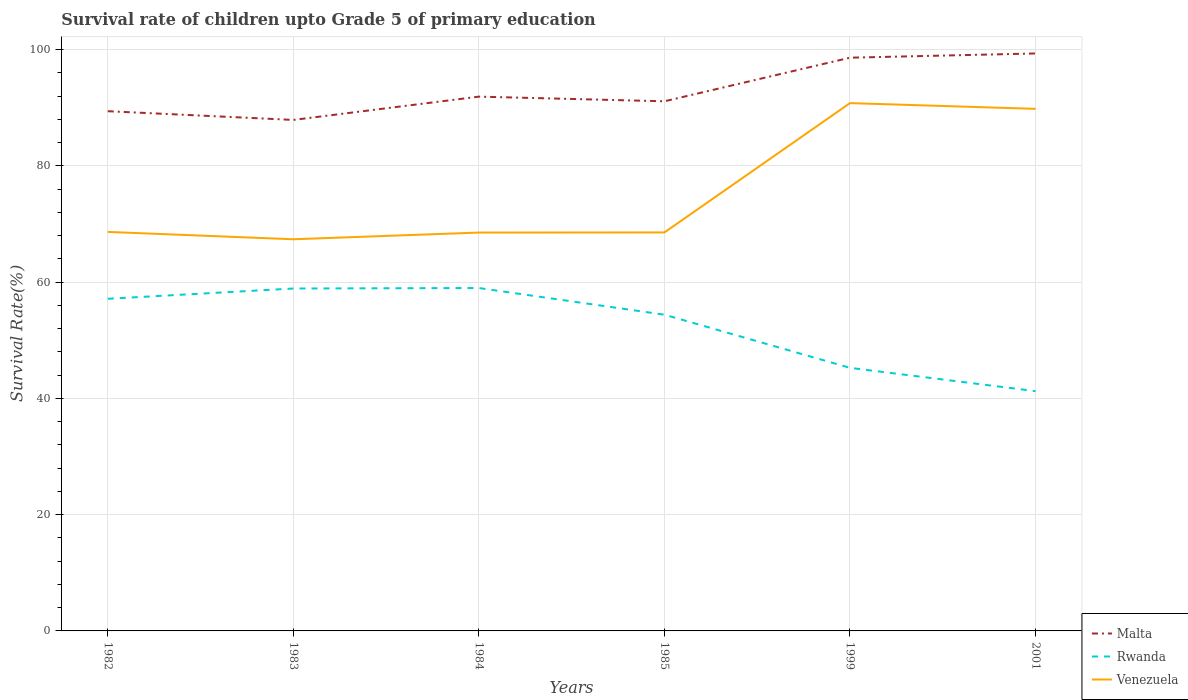How many different coloured lines are there?
Your answer should be compact. 3. Does the line corresponding to Venezuela intersect with the line corresponding to Rwanda?
Your answer should be very brief. No. Is the number of lines equal to the number of legend labels?
Offer a very short reply. Yes. Across all years, what is the maximum survival rate of children in Malta?
Make the answer very short. 87.9. What is the total survival rate of children in Rwanda in the graph?
Your response must be concise. 15.89. What is the difference between the highest and the second highest survival rate of children in Venezuela?
Offer a terse response. 23.42. How many lines are there?
Give a very brief answer. 3. Are the values on the major ticks of Y-axis written in scientific E-notation?
Your answer should be compact. No. Does the graph contain any zero values?
Your answer should be compact. No. How many legend labels are there?
Offer a terse response. 3. How are the legend labels stacked?
Make the answer very short. Vertical. What is the title of the graph?
Keep it short and to the point. Survival rate of children upto Grade 5 of primary education. Does "Virgin Islands" appear as one of the legend labels in the graph?
Give a very brief answer. No. What is the label or title of the X-axis?
Your response must be concise. Years. What is the label or title of the Y-axis?
Offer a terse response. Survival Rate(%). What is the Survival Rate(%) of Malta in 1982?
Offer a terse response. 89.4. What is the Survival Rate(%) in Rwanda in 1982?
Provide a succinct answer. 57.14. What is the Survival Rate(%) in Venezuela in 1982?
Ensure brevity in your answer.  68.64. What is the Survival Rate(%) of Malta in 1983?
Your answer should be compact. 87.9. What is the Survival Rate(%) in Rwanda in 1983?
Ensure brevity in your answer.  58.9. What is the Survival Rate(%) in Venezuela in 1983?
Make the answer very short. 67.37. What is the Survival Rate(%) of Malta in 1984?
Provide a succinct answer. 91.91. What is the Survival Rate(%) in Rwanda in 1984?
Ensure brevity in your answer.  58.99. What is the Survival Rate(%) of Venezuela in 1984?
Keep it short and to the point. 68.53. What is the Survival Rate(%) in Malta in 1985?
Ensure brevity in your answer.  91.11. What is the Survival Rate(%) in Rwanda in 1985?
Offer a terse response. 54.4. What is the Survival Rate(%) of Venezuela in 1985?
Offer a very short reply. 68.55. What is the Survival Rate(%) in Malta in 1999?
Your answer should be very brief. 98.61. What is the Survival Rate(%) of Rwanda in 1999?
Give a very brief answer. 45.26. What is the Survival Rate(%) in Venezuela in 1999?
Make the answer very short. 90.8. What is the Survival Rate(%) in Malta in 2001?
Offer a very short reply. 99.34. What is the Survival Rate(%) of Rwanda in 2001?
Ensure brevity in your answer.  41.25. What is the Survival Rate(%) of Venezuela in 2001?
Offer a very short reply. 89.81. Across all years, what is the maximum Survival Rate(%) of Malta?
Keep it short and to the point. 99.34. Across all years, what is the maximum Survival Rate(%) in Rwanda?
Keep it short and to the point. 58.99. Across all years, what is the maximum Survival Rate(%) in Venezuela?
Provide a short and direct response. 90.8. Across all years, what is the minimum Survival Rate(%) of Malta?
Your answer should be very brief. 87.9. Across all years, what is the minimum Survival Rate(%) in Rwanda?
Give a very brief answer. 41.25. Across all years, what is the minimum Survival Rate(%) of Venezuela?
Your response must be concise. 67.37. What is the total Survival Rate(%) of Malta in the graph?
Ensure brevity in your answer.  558.27. What is the total Survival Rate(%) of Rwanda in the graph?
Your answer should be compact. 315.93. What is the total Survival Rate(%) in Venezuela in the graph?
Make the answer very short. 453.7. What is the difference between the Survival Rate(%) of Malta in 1982 and that in 1983?
Your response must be concise. 1.5. What is the difference between the Survival Rate(%) of Rwanda in 1982 and that in 1983?
Your answer should be very brief. -1.77. What is the difference between the Survival Rate(%) of Venezuela in 1982 and that in 1983?
Your response must be concise. 1.26. What is the difference between the Survival Rate(%) of Malta in 1982 and that in 1984?
Offer a very short reply. -2.5. What is the difference between the Survival Rate(%) in Rwanda in 1982 and that in 1984?
Offer a very short reply. -1.85. What is the difference between the Survival Rate(%) in Venezuela in 1982 and that in 1984?
Provide a short and direct response. 0.11. What is the difference between the Survival Rate(%) in Malta in 1982 and that in 1985?
Your answer should be very brief. -1.7. What is the difference between the Survival Rate(%) of Rwanda in 1982 and that in 1985?
Provide a succinct answer. 2.74. What is the difference between the Survival Rate(%) of Venezuela in 1982 and that in 1985?
Offer a terse response. 0.09. What is the difference between the Survival Rate(%) in Malta in 1982 and that in 1999?
Your answer should be compact. -9.2. What is the difference between the Survival Rate(%) in Rwanda in 1982 and that in 1999?
Offer a very short reply. 11.88. What is the difference between the Survival Rate(%) in Venezuela in 1982 and that in 1999?
Offer a very short reply. -22.16. What is the difference between the Survival Rate(%) in Malta in 1982 and that in 2001?
Offer a very short reply. -9.93. What is the difference between the Survival Rate(%) of Rwanda in 1982 and that in 2001?
Keep it short and to the point. 15.89. What is the difference between the Survival Rate(%) of Venezuela in 1982 and that in 2001?
Provide a short and direct response. -21.17. What is the difference between the Survival Rate(%) of Malta in 1983 and that in 1984?
Give a very brief answer. -4.01. What is the difference between the Survival Rate(%) in Rwanda in 1983 and that in 1984?
Give a very brief answer. -0.09. What is the difference between the Survival Rate(%) of Venezuela in 1983 and that in 1984?
Give a very brief answer. -1.15. What is the difference between the Survival Rate(%) of Malta in 1983 and that in 1985?
Ensure brevity in your answer.  -3.21. What is the difference between the Survival Rate(%) of Rwanda in 1983 and that in 1985?
Provide a succinct answer. 4.5. What is the difference between the Survival Rate(%) of Venezuela in 1983 and that in 1985?
Ensure brevity in your answer.  -1.18. What is the difference between the Survival Rate(%) of Malta in 1983 and that in 1999?
Provide a short and direct response. -10.71. What is the difference between the Survival Rate(%) of Rwanda in 1983 and that in 1999?
Keep it short and to the point. 13.65. What is the difference between the Survival Rate(%) in Venezuela in 1983 and that in 1999?
Provide a succinct answer. -23.42. What is the difference between the Survival Rate(%) in Malta in 1983 and that in 2001?
Offer a very short reply. -11.44. What is the difference between the Survival Rate(%) in Rwanda in 1983 and that in 2001?
Offer a very short reply. 17.65. What is the difference between the Survival Rate(%) in Venezuela in 1983 and that in 2001?
Your answer should be compact. -22.43. What is the difference between the Survival Rate(%) of Malta in 1984 and that in 1985?
Your answer should be compact. 0.8. What is the difference between the Survival Rate(%) in Rwanda in 1984 and that in 1985?
Your response must be concise. 4.59. What is the difference between the Survival Rate(%) of Venezuela in 1984 and that in 1985?
Ensure brevity in your answer.  -0.02. What is the difference between the Survival Rate(%) of Malta in 1984 and that in 1999?
Ensure brevity in your answer.  -6.7. What is the difference between the Survival Rate(%) in Rwanda in 1984 and that in 1999?
Your response must be concise. 13.73. What is the difference between the Survival Rate(%) of Venezuela in 1984 and that in 1999?
Your answer should be compact. -22.27. What is the difference between the Survival Rate(%) of Malta in 1984 and that in 2001?
Your answer should be very brief. -7.43. What is the difference between the Survival Rate(%) of Rwanda in 1984 and that in 2001?
Offer a very short reply. 17.74. What is the difference between the Survival Rate(%) in Venezuela in 1984 and that in 2001?
Offer a very short reply. -21.28. What is the difference between the Survival Rate(%) in Malta in 1985 and that in 1999?
Your answer should be compact. -7.5. What is the difference between the Survival Rate(%) in Rwanda in 1985 and that in 1999?
Provide a succinct answer. 9.14. What is the difference between the Survival Rate(%) of Venezuela in 1985 and that in 1999?
Offer a very short reply. -22.25. What is the difference between the Survival Rate(%) of Malta in 1985 and that in 2001?
Provide a short and direct response. -8.23. What is the difference between the Survival Rate(%) in Rwanda in 1985 and that in 2001?
Make the answer very short. 13.15. What is the difference between the Survival Rate(%) in Venezuela in 1985 and that in 2001?
Make the answer very short. -21.26. What is the difference between the Survival Rate(%) in Malta in 1999 and that in 2001?
Your answer should be very brief. -0.73. What is the difference between the Survival Rate(%) of Rwanda in 1999 and that in 2001?
Give a very brief answer. 4.01. What is the difference between the Survival Rate(%) of Malta in 1982 and the Survival Rate(%) of Rwanda in 1983?
Provide a short and direct response. 30.5. What is the difference between the Survival Rate(%) in Malta in 1982 and the Survival Rate(%) in Venezuela in 1983?
Provide a short and direct response. 22.03. What is the difference between the Survival Rate(%) of Rwanda in 1982 and the Survival Rate(%) of Venezuela in 1983?
Provide a short and direct response. -10.24. What is the difference between the Survival Rate(%) of Malta in 1982 and the Survival Rate(%) of Rwanda in 1984?
Your response must be concise. 30.42. What is the difference between the Survival Rate(%) in Malta in 1982 and the Survival Rate(%) in Venezuela in 1984?
Provide a short and direct response. 20.88. What is the difference between the Survival Rate(%) of Rwanda in 1982 and the Survival Rate(%) of Venezuela in 1984?
Make the answer very short. -11.39. What is the difference between the Survival Rate(%) in Malta in 1982 and the Survival Rate(%) in Rwanda in 1985?
Provide a short and direct response. 35.01. What is the difference between the Survival Rate(%) of Malta in 1982 and the Survival Rate(%) of Venezuela in 1985?
Offer a terse response. 20.86. What is the difference between the Survival Rate(%) in Rwanda in 1982 and the Survival Rate(%) in Venezuela in 1985?
Offer a very short reply. -11.41. What is the difference between the Survival Rate(%) of Malta in 1982 and the Survival Rate(%) of Rwanda in 1999?
Keep it short and to the point. 44.15. What is the difference between the Survival Rate(%) of Malta in 1982 and the Survival Rate(%) of Venezuela in 1999?
Offer a terse response. -1.39. What is the difference between the Survival Rate(%) in Rwanda in 1982 and the Survival Rate(%) in Venezuela in 1999?
Make the answer very short. -33.66. What is the difference between the Survival Rate(%) in Malta in 1982 and the Survival Rate(%) in Rwanda in 2001?
Keep it short and to the point. 48.16. What is the difference between the Survival Rate(%) of Malta in 1982 and the Survival Rate(%) of Venezuela in 2001?
Give a very brief answer. -0.4. What is the difference between the Survival Rate(%) in Rwanda in 1982 and the Survival Rate(%) in Venezuela in 2001?
Give a very brief answer. -32.67. What is the difference between the Survival Rate(%) in Malta in 1983 and the Survival Rate(%) in Rwanda in 1984?
Provide a succinct answer. 28.91. What is the difference between the Survival Rate(%) of Malta in 1983 and the Survival Rate(%) of Venezuela in 1984?
Your answer should be very brief. 19.37. What is the difference between the Survival Rate(%) in Rwanda in 1983 and the Survival Rate(%) in Venezuela in 1984?
Keep it short and to the point. -9.62. What is the difference between the Survival Rate(%) in Malta in 1983 and the Survival Rate(%) in Rwanda in 1985?
Your answer should be very brief. 33.5. What is the difference between the Survival Rate(%) in Malta in 1983 and the Survival Rate(%) in Venezuela in 1985?
Ensure brevity in your answer.  19.35. What is the difference between the Survival Rate(%) in Rwanda in 1983 and the Survival Rate(%) in Venezuela in 1985?
Offer a terse response. -9.65. What is the difference between the Survival Rate(%) of Malta in 1983 and the Survival Rate(%) of Rwanda in 1999?
Provide a succinct answer. 42.64. What is the difference between the Survival Rate(%) in Malta in 1983 and the Survival Rate(%) in Venezuela in 1999?
Your answer should be very brief. -2.9. What is the difference between the Survival Rate(%) in Rwanda in 1983 and the Survival Rate(%) in Venezuela in 1999?
Make the answer very short. -31.89. What is the difference between the Survival Rate(%) of Malta in 1983 and the Survival Rate(%) of Rwanda in 2001?
Keep it short and to the point. 46.65. What is the difference between the Survival Rate(%) in Malta in 1983 and the Survival Rate(%) in Venezuela in 2001?
Offer a terse response. -1.91. What is the difference between the Survival Rate(%) in Rwanda in 1983 and the Survival Rate(%) in Venezuela in 2001?
Offer a terse response. -30.91. What is the difference between the Survival Rate(%) in Malta in 1984 and the Survival Rate(%) in Rwanda in 1985?
Make the answer very short. 37.51. What is the difference between the Survival Rate(%) in Malta in 1984 and the Survival Rate(%) in Venezuela in 1985?
Provide a short and direct response. 23.36. What is the difference between the Survival Rate(%) of Rwanda in 1984 and the Survival Rate(%) of Venezuela in 1985?
Your answer should be compact. -9.56. What is the difference between the Survival Rate(%) of Malta in 1984 and the Survival Rate(%) of Rwanda in 1999?
Your answer should be very brief. 46.65. What is the difference between the Survival Rate(%) in Malta in 1984 and the Survival Rate(%) in Venezuela in 1999?
Make the answer very short. 1.11. What is the difference between the Survival Rate(%) in Rwanda in 1984 and the Survival Rate(%) in Venezuela in 1999?
Your response must be concise. -31.81. What is the difference between the Survival Rate(%) of Malta in 1984 and the Survival Rate(%) of Rwanda in 2001?
Provide a succinct answer. 50.66. What is the difference between the Survival Rate(%) of Malta in 1984 and the Survival Rate(%) of Venezuela in 2001?
Provide a succinct answer. 2.1. What is the difference between the Survival Rate(%) in Rwanda in 1984 and the Survival Rate(%) in Venezuela in 2001?
Provide a short and direct response. -30.82. What is the difference between the Survival Rate(%) in Malta in 1985 and the Survival Rate(%) in Rwanda in 1999?
Your response must be concise. 45.85. What is the difference between the Survival Rate(%) in Malta in 1985 and the Survival Rate(%) in Venezuela in 1999?
Your response must be concise. 0.31. What is the difference between the Survival Rate(%) in Rwanda in 1985 and the Survival Rate(%) in Venezuela in 1999?
Your answer should be compact. -36.4. What is the difference between the Survival Rate(%) of Malta in 1985 and the Survival Rate(%) of Rwanda in 2001?
Provide a succinct answer. 49.86. What is the difference between the Survival Rate(%) in Malta in 1985 and the Survival Rate(%) in Venezuela in 2001?
Your answer should be compact. 1.3. What is the difference between the Survival Rate(%) of Rwanda in 1985 and the Survival Rate(%) of Venezuela in 2001?
Your answer should be very brief. -35.41. What is the difference between the Survival Rate(%) of Malta in 1999 and the Survival Rate(%) of Rwanda in 2001?
Keep it short and to the point. 57.36. What is the difference between the Survival Rate(%) of Malta in 1999 and the Survival Rate(%) of Venezuela in 2001?
Offer a very short reply. 8.8. What is the difference between the Survival Rate(%) of Rwanda in 1999 and the Survival Rate(%) of Venezuela in 2001?
Offer a terse response. -44.55. What is the average Survival Rate(%) of Malta per year?
Provide a short and direct response. 93.05. What is the average Survival Rate(%) of Rwanda per year?
Ensure brevity in your answer.  52.65. What is the average Survival Rate(%) of Venezuela per year?
Your answer should be compact. 75.62. In the year 1982, what is the difference between the Survival Rate(%) of Malta and Survival Rate(%) of Rwanda?
Make the answer very short. 32.27. In the year 1982, what is the difference between the Survival Rate(%) in Malta and Survival Rate(%) in Venezuela?
Your response must be concise. 20.77. In the year 1982, what is the difference between the Survival Rate(%) of Rwanda and Survival Rate(%) of Venezuela?
Make the answer very short. -11.5. In the year 1983, what is the difference between the Survival Rate(%) of Malta and Survival Rate(%) of Rwanda?
Provide a succinct answer. 29. In the year 1983, what is the difference between the Survival Rate(%) in Malta and Survival Rate(%) in Venezuela?
Your answer should be compact. 20.53. In the year 1983, what is the difference between the Survival Rate(%) of Rwanda and Survival Rate(%) of Venezuela?
Provide a short and direct response. -8.47. In the year 1984, what is the difference between the Survival Rate(%) of Malta and Survival Rate(%) of Rwanda?
Offer a very short reply. 32.92. In the year 1984, what is the difference between the Survival Rate(%) in Malta and Survival Rate(%) in Venezuela?
Your answer should be very brief. 23.38. In the year 1984, what is the difference between the Survival Rate(%) of Rwanda and Survival Rate(%) of Venezuela?
Offer a very short reply. -9.54. In the year 1985, what is the difference between the Survival Rate(%) of Malta and Survival Rate(%) of Rwanda?
Ensure brevity in your answer.  36.71. In the year 1985, what is the difference between the Survival Rate(%) in Malta and Survival Rate(%) in Venezuela?
Your response must be concise. 22.56. In the year 1985, what is the difference between the Survival Rate(%) in Rwanda and Survival Rate(%) in Venezuela?
Your answer should be compact. -14.15. In the year 1999, what is the difference between the Survival Rate(%) in Malta and Survival Rate(%) in Rwanda?
Give a very brief answer. 53.35. In the year 1999, what is the difference between the Survival Rate(%) in Malta and Survival Rate(%) in Venezuela?
Make the answer very short. 7.81. In the year 1999, what is the difference between the Survival Rate(%) of Rwanda and Survival Rate(%) of Venezuela?
Provide a succinct answer. -45.54. In the year 2001, what is the difference between the Survival Rate(%) in Malta and Survival Rate(%) in Rwanda?
Your answer should be very brief. 58.09. In the year 2001, what is the difference between the Survival Rate(%) in Malta and Survival Rate(%) in Venezuela?
Make the answer very short. 9.53. In the year 2001, what is the difference between the Survival Rate(%) in Rwanda and Survival Rate(%) in Venezuela?
Keep it short and to the point. -48.56. What is the ratio of the Survival Rate(%) of Malta in 1982 to that in 1983?
Keep it short and to the point. 1.02. What is the ratio of the Survival Rate(%) in Rwanda in 1982 to that in 1983?
Give a very brief answer. 0.97. What is the ratio of the Survival Rate(%) in Venezuela in 1982 to that in 1983?
Offer a very short reply. 1.02. What is the ratio of the Survival Rate(%) of Malta in 1982 to that in 1984?
Ensure brevity in your answer.  0.97. What is the ratio of the Survival Rate(%) in Rwanda in 1982 to that in 1984?
Your answer should be compact. 0.97. What is the ratio of the Survival Rate(%) of Venezuela in 1982 to that in 1984?
Keep it short and to the point. 1. What is the ratio of the Survival Rate(%) in Malta in 1982 to that in 1985?
Your response must be concise. 0.98. What is the ratio of the Survival Rate(%) of Rwanda in 1982 to that in 1985?
Keep it short and to the point. 1.05. What is the ratio of the Survival Rate(%) of Venezuela in 1982 to that in 1985?
Keep it short and to the point. 1. What is the ratio of the Survival Rate(%) in Malta in 1982 to that in 1999?
Give a very brief answer. 0.91. What is the ratio of the Survival Rate(%) in Rwanda in 1982 to that in 1999?
Make the answer very short. 1.26. What is the ratio of the Survival Rate(%) in Venezuela in 1982 to that in 1999?
Provide a succinct answer. 0.76. What is the ratio of the Survival Rate(%) of Malta in 1982 to that in 2001?
Provide a succinct answer. 0.9. What is the ratio of the Survival Rate(%) of Rwanda in 1982 to that in 2001?
Provide a short and direct response. 1.39. What is the ratio of the Survival Rate(%) in Venezuela in 1982 to that in 2001?
Your answer should be very brief. 0.76. What is the ratio of the Survival Rate(%) of Malta in 1983 to that in 1984?
Your response must be concise. 0.96. What is the ratio of the Survival Rate(%) of Rwanda in 1983 to that in 1984?
Your answer should be very brief. 1. What is the ratio of the Survival Rate(%) in Venezuela in 1983 to that in 1984?
Your answer should be compact. 0.98. What is the ratio of the Survival Rate(%) of Malta in 1983 to that in 1985?
Keep it short and to the point. 0.96. What is the ratio of the Survival Rate(%) of Rwanda in 1983 to that in 1985?
Offer a very short reply. 1.08. What is the ratio of the Survival Rate(%) in Venezuela in 1983 to that in 1985?
Keep it short and to the point. 0.98. What is the ratio of the Survival Rate(%) of Malta in 1983 to that in 1999?
Provide a short and direct response. 0.89. What is the ratio of the Survival Rate(%) in Rwanda in 1983 to that in 1999?
Keep it short and to the point. 1.3. What is the ratio of the Survival Rate(%) in Venezuela in 1983 to that in 1999?
Offer a very short reply. 0.74. What is the ratio of the Survival Rate(%) of Malta in 1983 to that in 2001?
Ensure brevity in your answer.  0.88. What is the ratio of the Survival Rate(%) in Rwanda in 1983 to that in 2001?
Provide a succinct answer. 1.43. What is the ratio of the Survival Rate(%) in Venezuela in 1983 to that in 2001?
Keep it short and to the point. 0.75. What is the ratio of the Survival Rate(%) of Malta in 1984 to that in 1985?
Provide a short and direct response. 1.01. What is the ratio of the Survival Rate(%) of Rwanda in 1984 to that in 1985?
Provide a short and direct response. 1.08. What is the ratio of the Survival Rate(%) in Venezuela in 1984 to that in 1985?
Provide a short and direct response. 1. What is the ratio of the Survival Rate(%) in Malta in 1984 to that in 1999?
Ensure brevity in your answer.  0.93. What is the ratio of the Survival Rate(%) in Rwanda in 1984 to that in 1999?
Your answer should be compact. 1.3. What is the ratio of the Survival Rate(%) in Venezuela in 1984 to that in 1999?
Make the answer very short. 0.75. What is the ratio of the Survival Rate(%) of Malta in 1984 to that in 2001?
Provide a short and direct response. 0.93. What is the ratio of the Survival Rate(%) of Rwanda in 1984 to that in 2001?
Give a very brief answer. 1.43. What is the ratio of the Survival Rate(%) in Venezuela in 1984 to that in 2001?
Keep it short and to the point. 0.76. What is the ratio of the Survival Rate(%) in Malta in 1985 to that in 1999?
Provide a succinct answer. 0.92. What is the ratio of the Survival Rate(%) of Rwanda in 1985 to that in 1999?
Offer a very short reply. 1.2. What is the ratio of the Survival Rate(%) of Venezuela in 1985 to that in 1999?
Ensure brevity in your answer.  0.76. What is the ratio of the Survival Rate(%) in Malta in 1985 to that in 2001?
Offer a terse response. 0.92. What is the ratio of the Survival Rate(%) of Rwanda in 1985 to that in 2001?
Your response must be concise. 1.32. What is the ratio of the Survival Rate(%) in Venezuela in 1985 to that in 2001?
Give a very brief answer. 0.76. What is the ratio of the Survival Rate(%) of Malta in 1999 to that in 2001?
Provide a succinct answer. 0.99. What is the ratio of the Survival Rate(%) in Rwanda in 1999 to that in 2001?
Keep it short and to the point. 1.1. What is the ratio of the Survival Rate(%) of Venezuela in 1999 to that in 2001?
Keep it short and to the point. 1.01. What is the difference between the highest and the second highest Survival Rate(%) of Malta?
Keep it short and to the point. 0.73. What is the difference between the highest and the second highest Survival Rate(%) in Rwanda?
Give a very brief answer. 0.09. What is the difference between the highest and the second highest Survival Rate(%) in Venezuela?
Offer a very short reply. 0.99. What is the difference between the highest and the lowest Survival Rate(%) of Malta?
Offer a terse response. 11.44. What is the difference between the highest and the lowest Survival Rate(%) in Rwanda?
Your answer should be very brief. 17.74. What is the difference between the highest and the lowest Survival Rate(%) in Venezuela?
Provide a succinct answer. 23.42. 